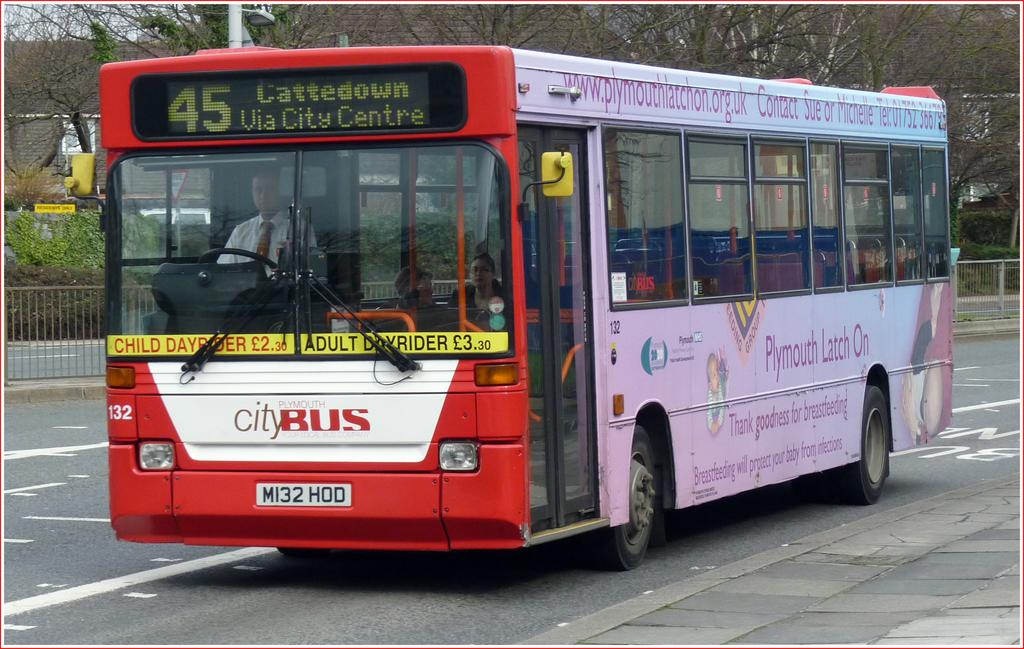<image>
Share a concise interpretation of the image provided. the word bus is on the front of a city bus 